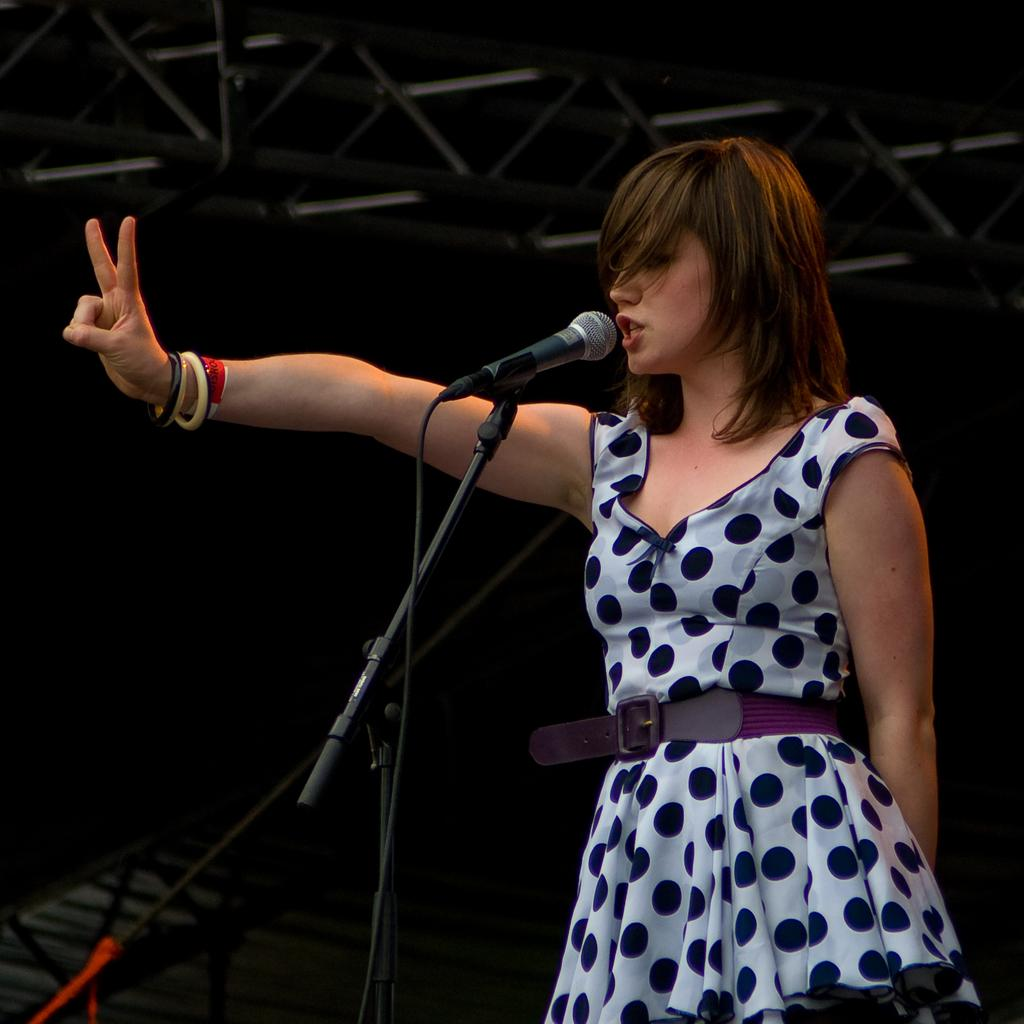What is the main subject of the image? There is a lady standing in the center of the image. What object is placed in front of the lady? There is a microphone placed on a stand before the lady. What can be seen at the top of the image? There are rods visible at the top of the image. How much income does the lady earn from her performance in the image? There is no information about the lady's income in the image, so it cannot be determined. 